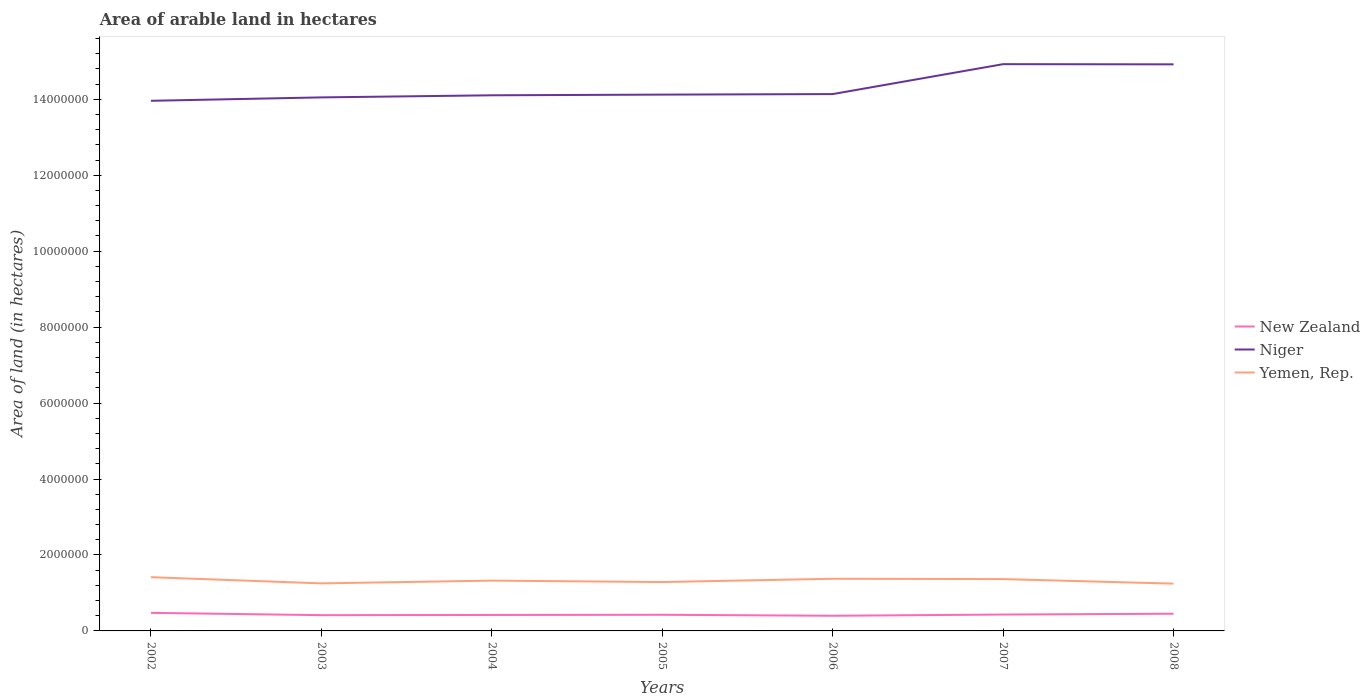How many different coloured lines are there?
Keep it short and to the point. 3. Does the line corresponding to New Zealand intersect with the line corresponding to Yemen, Rep.?
Provide a short and direct response. No. Is the number of lines equal to the number of legend labels?
Your response must be concise. Yes. Across all years, what is the maximum total arable land in Yemen, Rep.?
Your response must be concise. 1.24e+06. In which year was the total arable land in Yemen, Rep. maximum?
Offer a very short reply. 2008. What is the total total arable land in Niger in the graph?
Offer a terse response. -7.30e+04. What is the difference between the highest and the second highest total arable land in Niger?
Keep it short and to the point. 9.65e+05. What is the difference between the highest and the lowest total arable land in Niger?
Your answer should be very brief. 2. How many lines are there?
Give a very brief answer. 3. What is the difference between two consecutive major ticks on the Y-axis?
Your answer should be compact. 2.00e+06. Are the values on the major ticks of Y-axis written in scientific E-notation?
Ensure brevity in your answer.  No. Does the graph contain any zero values?
Keep it short and to the point. No. Where does the legend appear in the graph?
Ensure brevity in your answer.  Center right. What is the title of the graph?
Ensure brevity in your answer.  Area of arable land in hectares. What is the label or title of the X-axis?
Offer a very short reply. Years. What is the label or title of the Y-axis?
Ensure brevity in your answer.  Area of land (in hectares). What is the Area of land (in hectares) of New Zealand in 2002?
Your answer should be very brief. 4.76e+05. What is the Area of land (in hectares) in Niger in 2002?
Make the answer very short. 1.40e+07. What is the Area of land (in hectares) of Yemen, Rep. in 2002?
Make the answer very short. 1.42e+06. What is the Area of land (in hectares) of New Zealand in 2003?
Ensure brevity in your answer.  4.15e+05. What is the Area of land (in hectares) of Niger in 2003?
Keep it short and to the point. 1.40e+07. What is the Area of land (in hectares) of Yemen, Rep. in 2003?
Ensure brevity in your answer.  1.25e+06. What is the Area of land (in hectares) of New Zealand in 2004?
Offer a terse response. 4.20e+05. What is the Area of land (in hectares) in Niger in 2004?
Your answer should be compact. 1.41e+07. What is the Area of land (in hectares) in Yemen, Rep. in 2004?
Provide a succinct answer. 1.32e+06. What is the Area of land (in hectares) in New Zealand in 2005?
Make the answer very short. 4.25e+05. What is the Area of land (in hectares) of Niger in 2005?
Give a very brief answer. 1.41e+07. What is the Area of land (in hectares) in Yemen, Rep. in 2005?
Offer a very short reply. 1.29e+06. What is the Area of land (in hectares) in New Zealand in 2006?
Provide a short and direct response. 3.99e+05. What is the Area of land (in hectares) in Niger in 2006?
Keep it short and to the point. 1.41e+07. What is the Area of land (in hectares) in Yemen, Rep. in 2006?
Make the answer very short. 1.37e+06. What is the Area of land (in hectares) in New Zealand in 2007?
Your response must be concise. 4.31e+05. What is the Area of land (in hectares) of Niger in 2007?
Ensure brevity in your answer.  1.49e+07. What is the Area of land (in hectares) in Yemen, Rep. in 2007?
Ensure brevity in your answer.  1.36e+06. What is the Area of land (in hectares) in New Zealand in 2008?
Your answer should be very brief. 4.53e+05. What is the Area of land (in hectares) in Niger in 2008?
Offer a very short reply. 1.49e+07. What is the Area of land (in hectares) in Yemen, Rep. in 2008?
Give a very brief answer. 1.24e+06. Across all years, what is the maximum Area of land (in hectares) of New Zealand?
Offer a terse response. 4.76e+05. Across all years, what is the maximum Area of land (in hectares) in Niger?
Keep it short and to the point. 1.49e+07. Across all years, what is the maximum Area of land (in hectares) of Yemen, Rep.?
Ensure brevity in your answer.  1.42e+06. Across all years, what is the minimum Area of land (in hectares) of New Zealand?
Provide a succinct answer. 3.99e+05. Across all years, what is the minimum Area of land (in hectares) of Niger?
Your answer should be compact. 1.40e+07. Across all years, what is the minimum Area of land (in hectares) of Yemen, Rep.?
Ensure brevity in your answer.  1.24e+06. What is the total Area of land (in hectares) in New Zealand in the graph?
Provide a succinct answer. 3.02e+06. What is the total Area of land (in hectares) of Niger in the graph?
Your answer should be very brief. 1.00e+08. What is the total Area of land (in hectares) in Yemen, Rep. in the graph?
Ensure brevity in your answer.  9.26e+06. What is the difference between the Area of land (in hectares) of New Zealand in 2002 and that in 2003?
Your answer should be compact. 6.10e+04. What is the difference between the Area of land (in hectares) in Yemen, Rep. in 2002 and that in 2003?
Your answer should be very brief. 1.63e+05. What is the difference between the Area of land (in hectares) in New Zealand in 2002 and that in 2004?
Offer a very short reply. 5.60e+04. What is the difference between the Area of land (in hectares) in Niger in 2002 and that in 2004?
Offer a very short reply. -1.45e+05. What is the difference between the Area of land (in hectares) in New Zealand in 2002 and that in 2005?
Offer a terse response. 5.10e+04. What is the difference between the Area of land (in hectares) of Niger in 2002 and that in 2005?
Your answer should be compact. -1.63e+05. What is the difference between the Area of land (in hectares) in Yemen, Rep. in 2002 and that in 2005?
Make the answer very short. 1.28e+05. What is the difference between the Area of land (in hectares) of New Zealand in 2002 and that in 2006?
Your response must be concise. 7.70e+04. What is the difference between the Area of land (in hectares) of Niger in 2002 and that in 2006?
Offer a terse response. -1.77e+05. What is the difference between the Area of land (in hectares) in Yemen, Rep. in 2002 and that in 2006?
Make the answer very short. 4.10e+04. What is the difference between the Area of land (in hectares) in New Zealand in 2002 and that in 2007?
Your answer should be very brief. 4.50e+04. What is the difference between the Area of land (in hectares) of Niger in 2002 and that in 2007?
Provide a short and direct response. -9.65e+05. What is the difference between the Area of land (in hectares) of New Zealand in 2002 and that in 2008?
Offer a very short reply. 2.30e+04. What is the difference between the Area of land (in hectares) in Niger in 2002 and that in 2008?
Keep it short and to the point. -9.60e+05. What is the difference between the Area of land (in hectares) in New Zealand in 2003 and that in 2004?
Make the answer very short. -5000. What is the difference between the Area of land (in hectares) in Niger in 2003 and that in 2004?
Your response must be concise. -5.50e+04. What is the difference between the Area of land (in hectares) of Yemen, Rep. in 2003 and that in 2004?
Ensure brevity in your answer.  -7.30e+04. What is the difference between the Area of land (in hectares) of New Zealand in 2003 and that in 2005?
Your answer should be compact. -10000. What is the difference between the Area of land (in hectares) in Niger in 2003 and that in 2005?
Make the answer very short. -7.30e+04. What is the difference between the Area of land (in hectares) of Yemen, Rep. in 2003 and that in 2005?
Provide a short and direct response. -3.50e+04. What is the difference between the Area of land (in hectares) of New Zealand in 2003 and that in 2006?
Keep it short and to the point. 1.60e+04. What is the difference between the Area of land (in hectares) in Niger in 2003 and that in 2006?
Provide a short and direct response. -8.70e+04. What is the difference between the Area of land (in hectares) in Yemen, Rep. in 2003 and that in 2006?
Your answer should be compact. -1.22e+05. What is the difference between the Area of land (in hectares) in New Zealand in 2003 and that in 2007?
Your answer should be very brief. -1.60e+04. What is the difference between the Area of land (in hectares) in Niger in 2003 and that in 2007?
Keep it short and to the point. -8.75e+05. What is the difference between the Area of land (in hectares) of Yemen, Rep. in 2003 and that in 2007?
Provide a short and direct response. -1.13e+05. What is the difference between the Area of land (in hectares) of New Zealand in 2003 and that in 2008?
Your answer should be very brief. -3.80e+04. What is the difference between the Area of land (in hectares) of Niger in 2003 and that in 2008?
Your answer should be compact. -8.70e+05. What is the difference between the Area of land (in hectares) of Yemen, Rep. in 2003 and that in 2008?
Your answer should be compact. 7000. What is the difference between the Area of land (in hectares) in New Zealand in 2004 and that in 2005?
Offer a terse response. -5000. What is the difference between the Area of land (in hectares) in Niger in 2004 and that in 2005?
Keep it short and to the point. -1.80e+04. What is the difference between the Area of land (in hectares) of Yemen, Rep. in 2004 and that in 2005?
Your response must be concise. 3.80e+04. What is the difference between the Area of land (in hectares) of New Zealand in 2004 and that in 2006?
Make the answer very short. 2.10e+04. What is the difference between the Area of land (in hectares) of Niger in 2004 and that in 2006?
Offer a very short reply. -3.20e+04. What is the difference between the Area of land (in hectares) in Yemen, Rep. in 2004 and that in 2006?
Offer a very short reply. -4.90e+04. What is the difference between the Area of land (in hectares) of New Zealand in 2004 and that in 2007?
Ensure brevity in your answer.  -1.10e+04. What is the difference between the Area of land (in hectares) in Niger in 2004 and that in 2007?
Offer a very short reply. -8.20e+05. What is the difference between the Area of land (in hectares) of Yemen, Rep. in 2004 and that in 2007?
Make the answer very short. -4.00e+04. What is the difference between the Area of land (in hectares) in New Zealand in 2004 and that in 2008?
Provide a short and direct response. -3.30e+04. What is the difference between the Area of land (in hectares) of Niger in 2004 and that in 2008?
Offer a terse response. -8.15e+05. What is the difference between the Area of land (in hectares) in New Zealand in 2005 and that in 2006?
Keep it short and to the point. 2.60e+04. What is the difference between the Area of land (in hectares) of Niger in 2005 and that in 2006?
Your answer should be compact. -1.40e+04. What is the difference between the Area of land (in hectares) of Yemen, Rep. in 2005 and that in 2006?
Give a very brief answer. -8.70e+04. What is the difference between the Area of land (in hectares) of New Zealand in 2005 and that in 2007?
Your answer should be very brief. -6000. What is the difference between the Area of land (in hectares) in Niger in 2005 and that in 2007?
Keep it short and to the point. -8.02e+05. What is the difference between the Area of land (in hectares) in Yemen, Rep. in 2005 and that in 2007?
Your response must be concise. -7.80e+04. What is the difference between the Area of land (in hectares) of New Zealand in 2005 and that in 2008?
Offer a terse response. -2.80e+04. What is the difference between the Area of land (in hectares) in Niger in 2005 and that in 2008?
Offer a terse response. -7.97e+05. What is the difference between the Area of land (in hectares) in Yemen, Rep. in 2005 and that in 2008?
Provide a succinct answer. 4.20e+04. What is the difference between the Area of land (in hectares) of New Zealand in 2006 and that in 2007?
Provide a succinct answer. -3.20e+04. What is the difference between the Area of land (in hectares) of Niger in 2006 and that in 2007?
Offer a terse response. -7.88e+05. What is the difference between the Area of land (in hectares) of Yemen, Rep. in 2006 and that in 2007?
Your answer should be very brief. 9000. What is the difference between the Area of land (in hectares) in New Zealand in 2006 and that in 2008?
Your answer should be compact. -5.40e+04. What is the difference between the Area of land (in hectares) in Niger in 2006 and that in 2008?
Offer a terse response. -7.83e+05. What is the difference between the Area of land (in hectares) of Yemen, Rep. in 2006 and that in 2008?
Your answer should be very brief. 1.29e+05. What is the difference between the Area of land (in hectares) of New Zealand in 2007 and that in 2008?
Your answer should be compact. -2.20e+04. What is the difference between the Area of land (in hectares) of New Zealand in 2002 and the Area of land (in hectares) of Niger in 2003?
Your response must be concise. -1.36e+07. What is the difference between the Area of land (in hectares) of New Zealand in 2002 and the Area of land (in hectares) of Yemen, Rep. in 2003?
Keep it short and to the point. -7.76e+05. What is the difference between the Area of land (in hectares) in Niger in 2002 and the Area of land (in hectares) in Yemen, Rep. in 2003?
Make the answer very short. 1.27e+07. What is the difference between the Area of land (in hectares) in New Zealand in 2002 and the Area of land (in hectares) in Niger in 2004?
Your answer should be very brief. -1.36e+07. What is the difference between the Area of land (in hectares) of New Zealand in 2002 and the Area of land (in hectares) of Yemen, Rep. in 2004?
Your answer should be compact. -8.49e+05. What is the difference between the Area of land (in hectares) of Niger in 2002 and the Area of land (in hectares) of Yemen, Rep. in 2004?
Make the answer very short. 1.26e+07. What is the difference between the Area of land (in hectares) of New Zealand in 2002 and the Area of land (in hectares) of Niger in 2005?
Offer a terse response. -1.36e+07. What is the difference between the Area of land (in hectares) of New Zealand in 2002 and the Area of land (in hectares) of Yemen, Rep. in 2005?
Ensure brevity in your answer.  -8.11e+05. What is the difference between the Area of land (in hectares) of Niger in 2002 and the Area of land (in hectares) of Yemen, Rep. in 2005?
Your answer should be very brief. 1.27e+07. What is the difference between the Area of land (in hectares) of New Zealand in 2002 and the Area of land (in hectares) of Niger in 2006?
Make the answer very short. -1.37e+07. What is the difference between the Area of land (in hectares) of New Zealand in 2002 and the Area of land (in hectares) of Yemen, Rep. in 2006?
Provide a short and direct response. -8.98e+05. What is the difference between the Area of land (in hectares) in Niger in 2002 and the Area of land (in hectares) in Yemen, Rep. in 2006?
Provide a short and direct response. 1.26e+07. What is the difference between the Area of land (in hectares) of New Zealand in 2002 and the Area of land (in hectares) of Niger in 2007?
Keep it short and to the point. -1.44e+07. What is the difference between the Area of land (in hectares) of New Zealand in 2002 and the Area of land (in hectares) of Yemen, Rep. in 2007?
Your answer should be compact. -8.89e+05. What is the difference between the Area of land (in hectares) in Niger in 2002 and the Area of land (in hectares) in Yemen, Rep. in 2007?
Your answer should be very brief. 1.26e+07. What is the difference between the Area of land (in hectares) of New Zealand in 2002 and the Area of land (in hectares) of Niger in 2008?
Offer a very short reply. -1.44e+07. What is the difference between the Area of land (in hectares) in New Zealand in 2002 and the Area of land (in hectares) in Yemen, Rep. in 2008?
Keep it short and to the point. -7.69e+05. What is the difference between the Area of land (in hectares) of Niger in 2002 and the Area of land (in hectares) of Yemen, Rep. in 2008?
Provide a succinct answer. 1.27e+07. What is the difference between the Area of land (in hectares) in New Zealand in 2003 and the Area of land (in hectares) in Niger in 2004?
Provide a short and direct response. -1.37e+07. What is the difference between the Area of land (in hectares) of New Zealand in 2003 and the Area of land (in hectares) of Yemen, Rep. in 2004?
Give a very brief answer. -9.10e+05. What is the difference between the Area of land (in hectares) in Niger in 2003 and the Area of land (in hectares) in Yemen, Rep. in 2004?
Ensure brevity in your answer.  1.27e+07. What is the difference between the Area of land (in hectares) in New Zealand in 2003 and the Area of land (in hectares) in Niger in 2005?
Make the answer very short. -1.37e+07. What is the difference between the Area of land (in hectares) of New Zealand in 2003 and the Area of land (in hectares) of Yemen, Rep. in 2005?
Keep it short and to the point. -8.72e+05. What is the difference between the Area of land (in hectares) in Niger in 2003 and the Area of land (in hectares) in Yemen, Rep. in 2005?
Provide a short and direct response. 1.28e+07. What is the difference between the Area of land (in hectares) of New Zealand in 2003 and the Area of land (in hectares) of Niger in 2006?
Give a very brief answer. -1.37e+07. What is the difference between the Area of land (in hectares) in New Zealand in 2003 and the Area of land (in hectares) in Yemen, Rep. in 2006?
Your response must be concise. -9.59e+05. What is the difference between the Area of land (in hectares) in Niger in 2003 and the Area of land (in hectares) in Yemen, Rep. in 2006?
Ensure brevity in your answer.  1.27e+07. What is the difference between the Area of land (in hectares) in New Zealand in 2003 and the Area of land (in hectares) in Niger in 2007?
Provide a short and direct response. -1.45e+07. What is the difference between the Area of land (in hectares) of New Zealand in 2003 and the Area of land (in hectares) of Yemen, Rep. in 2007?
Keep it short and to the point. -9.50e+05. What is the difference between the Area of land (in hectares) of Niger in 2003 and the Area of land (in hectares) of Yemen, Rep. in 2007?
Provide a succinct answer. 1.27e+07. What is the difference between the Area of land (in hectares) in New Zealand in 2003 and the Area of land (in hectares) in Niger in 2008?
Your answer should be very brief. -1.45e+07. What is the difference between the Area of land (in hectares) in New Zealand in 2003 and the Area of land (in hectares) in Yemen, Rep. in 2008?
Offer a very short reply. -8.30e+05. What is the difference between the Area of land (in hectares) in Niger in 2003 and the Area of land (in hectares) in Yemen, Rep. in 2008?
Your response must be concise. 1.28e+07. What is the difference between the Area of land (in hectares) in New Zealand in 2004 and the Area of land (in hectares) in Niger in 2005?
Give a very brief answer. -1.37e+07. What is the difference between the Area of land (in hectares) of New Zealand in 2004 and the Area of land (in hectares) of Yemen, Rep. in 2005?
Give a very brief answer. -8.67e+05. What is the difference between the Area of land (in hectares) in Niger in 2004 and the Area of land (in hectares) in Yemen, Rep. in 2005?
Your answer should be very brief. 1.28e+07. What is the difference between the Area of land (in hectares) of New Zealand in 2004 and the Area of land (in hectares) of Niger in 2006?
Your answer should be very brief. -1.37e+07. What is the difference between the Area of land (in hectares) in New Zealand in 2004 and the Area of land (in hectares) in Yemen, Rep. in 2006?
Give a very brief answer. -9.54e+05. What is the difference between the Area of land (in hectares) in Niger in 2004 and the Area of land (in hectares) in Yemen, Rep. in 2006?
Your answer should be very brief. 1.27e+07. What is the difference between the Area of land (in hectares) in New Zealand in 2004 and the Area of land (in hectares) in Niger in 2007?
Offer a terse response. -1.45e+07. What is the difference between the Area of land (in hectares) in New Zealand in 2004 and the Area of land (in hectares) in Yemen, Rep. in 2007?
Your answer should be compact. -9.45e+05. What is the difference between the Area of land (in hectares) of Niger in 2004 and the Area of land (in hectares) of Yemen, Rep. in 2007?
Provide a short and direct response. 1.27e+07. What is the difference between the Area of land (in hectares) in New Zealand in 2004 and the Area of land (in hectares) in Niger in 2008?
Your answer should be very brief. -1.45e+07. What is the difference between the Area of land (in hectares) of New Zealand in 2004 and the Area of land (in hectares) of Yemen, Rep. in 2008?
Ensure brevity in your answer.  -8.25e+05. What is the difference between the Area of land (in hectares) in Niger in 2004 and the Area of land (in hectares) in Yemen, Rep. in 2008?
Your response must be concise. 1.29e+07. What is the difference between the Area of land (in hectares) of New Zealand in 2005 and the Area of land (in hectares) of Niger in 2006?
Offer a terse response. -1.37e+07. What is the difference between the Area of land (in hectares) in New Zealand in 2005 and the Area of land (in hectares) in Yemen, Rep. in 2006?
Keep it short and to the point. -9.49e+05. What is the difference between the Area of land (in hectares) of Niger in 2005 and the Area of land (in hectares) of Yemen, Rep. in 2006?
Make the answer very short. 1.27e+07. What is the difference between the Area of land (in hectares) in New Zealand in 2005 and the Area of land (in hectares) in Niger in 2007?
Your response must be concise. -1.45e+07. What is the difference between the Area of land (in hectares) of New Zealand in 2005 and the Area of land (in hectares) of Yemen, Rep. in 2007?
Offer a very short reply. -9.40e+05. What is the difference between the Area of land (in hectares) in Niger in 2005 and the Area of land (in hectares) in Yemen, Rep. in 2007?
Provide a succinct answer. 1.28e+07. What is the difference between the Area of land (in hectares) in New Zealand in 2005 and the Area of land (in hectares) in Niger in 2008?
Make the answer very short. -1.45e+07. What is the difference between the Area of land (in hectares) of New Zealand in 2005 and the Area of land (in hectares) of Yemen, Rep. in 2008?
Offer a terse response. -8.20e+05. What is the difference between the Area of land (in hectares) in Niger in 2005 and the Area of land (in hectares) in Yemen, Rep. in 2008?
Keep it short and to the point. 1.29e+07. What is the difference between the Area of land (in hectares) in New Zealand in 2006 and the Area of land (in hectares) in Niger in 2007?
Your response must be concise. -1.45e+07. What is the difference between the Area of land (in hectares) in New Zealand in 2006 and the Area of land (in hectares) in Yemen, Rep. in 2007?
Your answer should be very brief. -9.66e+05. What is the difference between the Area of land (in hectares) in Niger in 2006 and the Area of land (in hectares) in Yemen, Rep. in 2007?
Your answer should be compact. 1.28e+07. What is the difference between the Area of land (in hectares) in New Zealand in 2006 and the Area of land (in hectares) in Niger in 2008?
Keep it short and to the point. -1.45e+07. What is the difference between the Area of land (in hectares) in New Zealand in 2006 and the Area of land (in hectares) in Yemen, Rep. in 2008?
Offer a terse response. -8.46e+05. What is the difference between the Area of land (in hectares) in Niger in 2006 and the Area of land (in hectares) in Yemen, Rep. in 2008?
Your answer should be compact. 1.29e+07. What is the difference between the Area of land (in hectares) of New Zealand in 2007 and the Area of land (in hectares) of Niger in 2008?
Give a very brief answer. -1.45e+07. What is the difference between the Area of land (in hectares) in New Zealand in 2007 and the Area of land (in hectares) in Yemen, Rep. in 2008?
Offer a terse response. -8.14e+05. What is the difference between the Area of land (in hectares) of Niger in 2007 and the Area of land (in hectares) of Yemen, Rep. in 2008?
Your response must be concise. 1.37e+07. What is the average Area of land (in hectares) in New Zealand per year?
Give a very brief answer. 4.31e+05. What is the average Area of land (in hectares) in Niger per year?
Your answer should be very brief. 1.43e+07. What is the average Area of land (in hectares) in Yemen, Rep. per year?
Make the answer very short. 1.32e+06. In the year 2002, what is the difference between the Area of land (in hectares) of New Zealand and Area of land (in hectares) of Niger?
Offer a terse response. -1.35e+07. In the year 2002, what is the difference between the Area of land (in hectares) of New Zealand and Area of land (in hectares) of Yemen, Rep.?
Offer a terse response. -9.39e+05. In the year 2002, what is the difference between the Area of land (in hectares) of Niger and Area of land (in hectares) of Yemen, Rep.?
Your answer should be very brief. 1.25e+07. In the year 2003, what is the difference between the Area of land (in hectares) in New Zealand and Area of land (in hectares) in Niger?
Provide a succinct answer. -1.36e+07. In the year 2003, what is the difference between the Area of land (in hectares) of New Zealand and Area of land (in hectares) of Yemen, Rep.?
Your answer should be very brief. -8.37e+05. In the year 2003, what is the difference between the Area of land (in hectares) of Niger and Area of land (in hectares) of Yemen, Rep.?
Offer a very short reply. 1.28e+07. In the year 2004, what is the difference between the Area of land (in hectares) of New Zealand and Area of land (in hectares) of Niger?
Offer a very short reply. -1.37e+07. In the year 2004, what is the difference between the Area of land (in hectares) of New Zealand and Area of land (in hectares) of Yemen, Rep.?
Provide a short and direct response. -9.05e+05. In the year 2004, what is the difference between the Area of land (in hectares) of Niger and Area of land (in hectares) of Yemen, Rep.?
Make the answer very short. 1.28e+07. In the year 2005, what is the difference between the Area of land (in hectares) of New Zealand and Area of land (in hectares) of Niger?
Your response must be concise. -1.37e+07. In the year 2005, what is the difference between the Area of land (in hectares) of New Zealand and Area of land (in hectares) of Yemen, Rep.?
Provide a succinct answer. -8.62e+05. In the year 2005, what is the difference between the Area of land (in hectares) of Niger and Area of land (in hectares) of Yemen, Rep.?
Offer a terse response. 1.28e+07. In the year 2006, what is the difference between the Area of land (in hectares) of New Zealand and Area of land (in hectares) of Niger?
Your answer should be very brief. -1.37e+07. In the year 2006, what is the difference between the Area of land (in hectares) of New Zealand and Area of land (in hectares) of Yemen, Rep.?
Provide a succinct answer. -9.75e+05. In the year 2006, what is the difference between the Area of land (in hectares) of Niger and Area of land (in hectares) of Yemen, Rep.?
Give a very brief answer. 1.28e+07. In the year 2007, what is the difference between the Area of land (in hectares) of New Zealand and Area of land (in hectares) of Niger?
Your response must be concise. -1.45e+07. In the year 2007, what is the difference between the Area of land (in hectares) in New Zealand and Area of land (in hectares) in Yemen, Rep.?
Your response must be concise. -9.34e+05. In the year 2007, what is the difference between the Area of land (in hectares) in Niger and Area of land (in hectares) in Yemen, Rep.?
Offer a terse response. 1.36e+07. In the year 2008, what is the difference between the Area of land (in hectares) of New Zealand and Area of land (in hectares) of Niger?
Make the answer very short. -1.45e+07. In the year 2008, what is the difference between the Area of land (in hectares) of New Zealand and Area of land (in hectares) of Yemen, Rep.?
Ensure brevity in your answer.  -7.92e+05. In the year 2008, what is the difference between the Area of land (in hectares) in Niger and Area of land (in hectares) in Yemen, Rep.?
Make the answer very short. 1.37e+07. What is the ratio of the Area of land (in hectares) in New Zealand in 2002 to that in 2003?
Give a very brief answer. 1.15. What is the ratio of the Area of land (in hectares) of Niger in 2002 to that in 2003?
Provide a succinct answer. 0.99. What is the ratio of the Area of land (in hectares) of Yemen, Rep. in 2002 to that in 2003?
Offer a terse response. 1.13. What is the ratio of the Area of land (in hectares) of New Zealand in 2002 to that in 2004?
Keep it short and to the point. 1.13. What is the ratio of the Area of land (in hectares) in Yemen, Rep. in 2002 to that in 2004?
Offer a very short reply. 1.07. What is the ratio of the Area of land (in hectares) in New Zealand in 2002 to that in 2005?
Provide a succinct answer. 1.12. What is the ratio of the Area of land (in hectares) of Yemen, Rep. in 2002 to that in 2005?
Offer a terse response. 1.1. What is the ratio of the Area of land (in hectares) in New Zealand in 2002 to that in 2006?
Provide a succinct answer. 1.19. What is the ratio of the Area of land (in hectares) in Niger in 2002 to that in 2006?
Give a very brief answer. 0.99. What is the ratio of the Area of land (in hectares) in Yemen, Rep. in 2002 to that in 2006?
Your answer should be very brief. 1.03. What is the ratio of the Area of land (in hectares) in New Zealand in 2002 to that in 2007?
Provide a short and direct response. 1.1. What is the ratio of the Area of land (in hectares) in Niger in 2002 to that in 2007?
Your answer should be compact. 0.94. What is the ratio of the Area of land (in hectares) of Yemen, Rep. in 2002 to that in 2007?
Ensure brevity in your answer.  1.04. What is the ratio of the Area of land (in hectares) in New Zealand in 2002 to that in 2008?
Your answer should be compact. 1.05. What is the ratio of the Area of land (in hectares) of Niger in 2002 to that in 2008?
Provide a succinct answer. 0.94. What is the ratio of the Area of land (in hectares) in Yemen, Rep. in 2002 to that in 2008?
Offer a terse response. 1.14. What is the ratio of the Area of land (in hectares) in Yemen, Rep. in 2003 to that in 2004?
Offer a terse response. 0.94. What is the ratio of the Area of land (in hectares) in New Zealand in 2003 to that in 2005?
Keep it short and to the point. 0.98. What is the ratio of the Area of land (in hectares) of Niger in 2003 to that in 2005?
Make the answer very short. 0.99. What is the ratio of the Area of land (in hectares) in Yemen, Rep. in 2003 to that in 2005?
Your response must be concise. 0.97. What is the ratio of the Area of land (in hectares) of New Zealand in 2003 to that in 2006?
Your answer should be compact. 1.04. What is the ratio of the Area of land (in hectares) of Niger in 2003 to that in 2006?
Your answer should be very brief. 0.99. What is the ratio of the Area of land (in hectares) in Yemen, Rep. in 2003 to that in 2006?
Give a very brief answer. 0.91. What is the ratio of the Area of land (in hectares) in New Zealand in 2003 to that in 2007?
Your answer should be compact. 0.96. What is the ratio of the Area of land (in hectares) of Niger in 2003 to that in 2007?
Give a very brief answer. 0.94. What is the ratio of the Area of land (in hectares) of Yemen, Rep. in 2003 to that in 2007?
Your answer should be very brief. 0.92. What is the ratio of the Area of land (in hectares) of New Zealand in 2003 to that in 2008?
Provide a short and direct response. 0.92. What is the ratio of the Area of land (in hectares) in Niger in 2003 to that in 2008?
Offer a very short reply. 0.94. What is the ratio of the Area of land (in hectares) in Yemen, Rep. in 2003 to that in 2008?
Offer a terse response. 1.01. What is the ratio of the Area of land (in hectares) of New Zealand in 2004 to that in 2005?
Give a very brief answer. 0.99. What is the ratio of the Area of land (in hectares) of Niger in 2004 to that in 2005?
Your answer should be compact. 1. What is the ratio of the Area of land (in hectares) in Yemen, Rep. in 2004 to that in 2005?
Provide a succinct answer. 1.03. What is the ratio of the Area of land (in hectares) of New Zealand in 2004 to that in 2006?
Keep it short and to the point. 1.05. What is the ratio of the Area of land (in hectares) of Niger in 2004 to that in 2006?
Your response must be concise. 1. What is the ratio of the Area of land (in hectares) of New Zealand in 2004 to that in 2007?
Your answer should be compact. 0.97. What is the ratio of the Area of land (in hectares) in Niger in 2004 to that in 2007?
Make the answer very short. 0.95. What is the ratio of the Area of land (in hectares) of Yemen, Rep. in 2004 to that in 2007?
Provide a succinct answer. 0.97. What is the ratio of the Area of land (in hectares) of New Zealand in 2004 to that in 2008?
Provide a short and direct response. 0.93. What is the ratio of the Area of land (in hectares) of Niger in 2004 to that in 2008?
Ensure brevity in your answer.  0.95. What is the ratio of the Area of land (in hectares) of Yemen, Rep. in 2004 to that in 2008?
Your response must be concise. 1.06. What is the ratio of the Area of land (in hectares) of New Zealand in 2005 to that in 2006?
Your answer should be very brief. 1.07. What is the ratio of the Area of land (in hectares) in Niger in 2005 to that in 2006?
Provide a succinct answer. 1. What is the ratio of the Area of land (in hectares) in Yemen, Rep. in 2005 to that in 2006?
Make the answer very short. 0.94. What is the ratio of the Area of land (in hectares) in New Zealand in 2005 to that in 2007?
Make the answer very short. 0.99. What is the ratio of the Area of land (in hectares) in Niger in 2005 to that in 2007?
Offer a very short reply. 0.95. What is the ratio of the Area of land (in hectares) in Yemen, Rep. in 2005 to that in 2007?
Provide a short and direct response. 0.94. What is the ratio of the Area of land (in hectares) of New Zealand in 2005 to that in 2008?
Give a very brief answer. 0.94. What is the ratio of the Area of land (in hectares) in Niger in 2005 to that in 2008?
Provide a succinct answer. 0.95. What is the ratio of the Area of land (in hectares) of Yemen, Rep. in 2005 to that in 2008?
Ensure brevity in your answer.  1.03. What is the ratio of the Area of land (in hectares) of New Zealand in 2006 to that in 2007?
Provide a succinct answer. 0.93. What is the ratio of the Area of land (in hectares) in Niger in 2006 to that in 2007?
Your answer should be very brief. 0.95. What is the ratio of the Area of land (in hectares) of Yemen, Rep. in 2006 to that in 2007?
Provide a short and direct response. 1.01. What is the ratio of the Area of land (in hectares) in New Zealand in 2006 to that in 2008?
Provide a succinct answer. 0.88. What is the ratio of the Area of land (in hectares) in Niger in 2006 to that in 2008?
Offer a terse response. 0.95. What is the ratio of the Area of land (in hectares) of Yemen, Rep. in 2006 to that in 2008?
Offer a very short reply. 1.1. What is the ratio of the Area of land (in hectares) in New Zealand in 2007 to that in 2008?
Your answer should be compact. 0.95. What is the ratio of the Area of land (in hectares) in Niger in 2007 to that in 2008?
Give a very brief answer. 1. What is the ratio of the Area of land (in hectares) in Yemen, Rep. in 2007 to that in 2008?
Offer a terse response. 1.1. What is the difference between the highest and the second highest Area of land (in hectares) in New Zealand?
Your answer should be very brief. 2.30e+04. What is the difference between the highest and the second highest Area of land (in hectares) of Yemen, Rep.?
Provide a succinct answer. 4.10e+04. What is the difference between the highest and the lowest Area of land (in hectares) of New Zealand?
Offer a very short reply. 7.70e+04. What is the difference between the highest and the lowest Area of land (in hectares) of Niger?
Ensure brevity in your answer.  9.65e+05. 